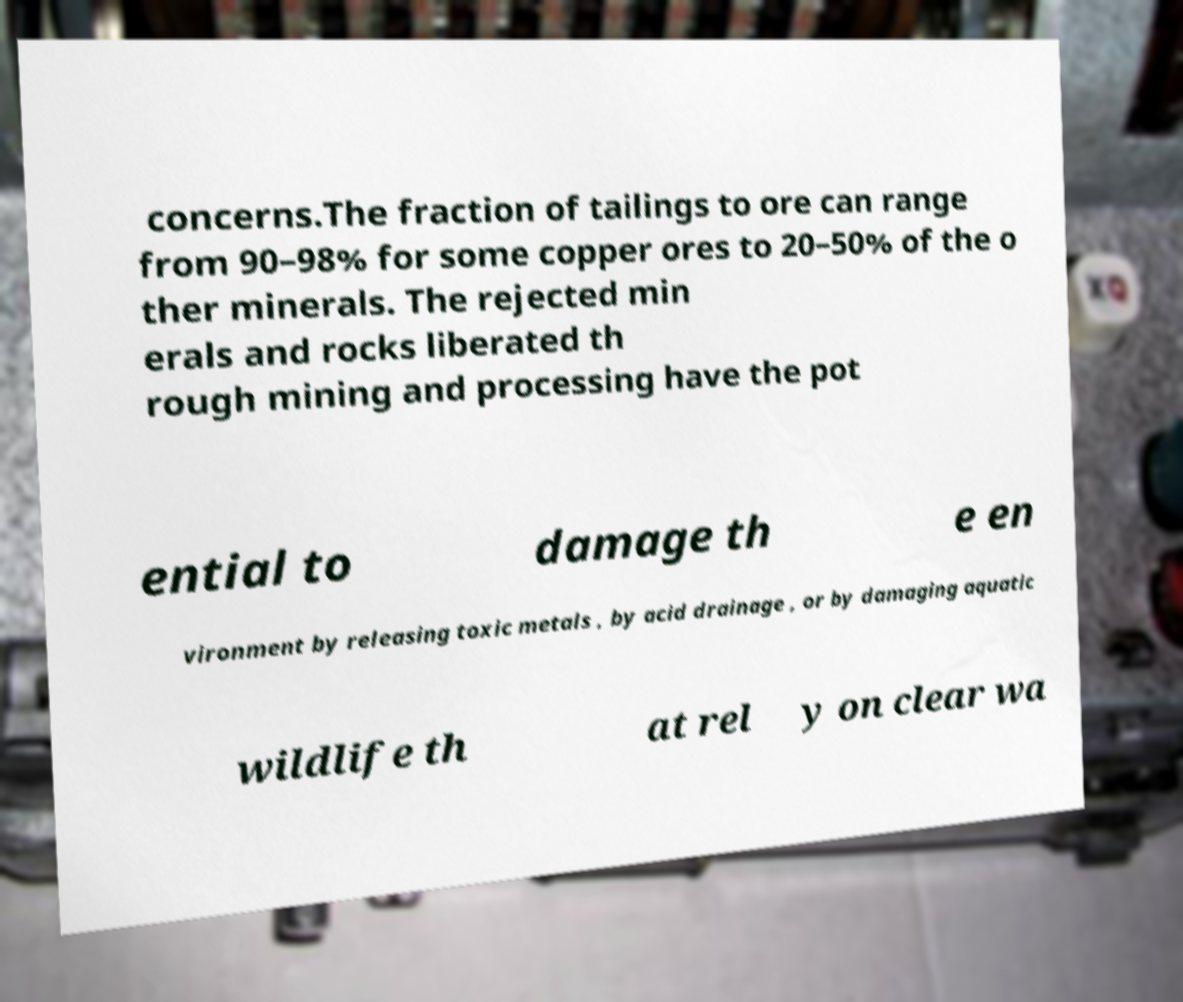Can you read and provide the text displayed in the image?This photo seems to have some interesting text. Can you extract and type it out for me? concerns.The fraction of tailings to ore can range from 90–98% for some copper ores to 20–50% of the o ther minerals. The rejected min erals and rocks liberated th rough mining and processing have the pot ential to damage th e en vironment by releasing toxic metals , by acid drainage , or by damaging aquatic wildlife th at rel y on clear wa 